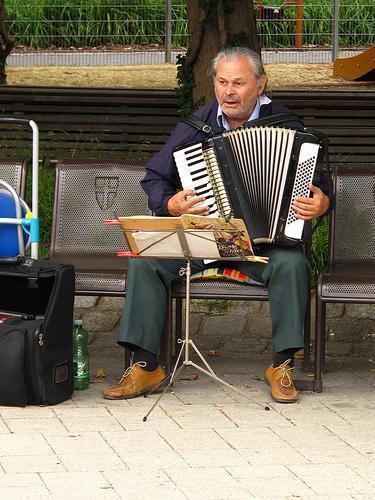How many people are there?
Give a very brief answer. 1. 